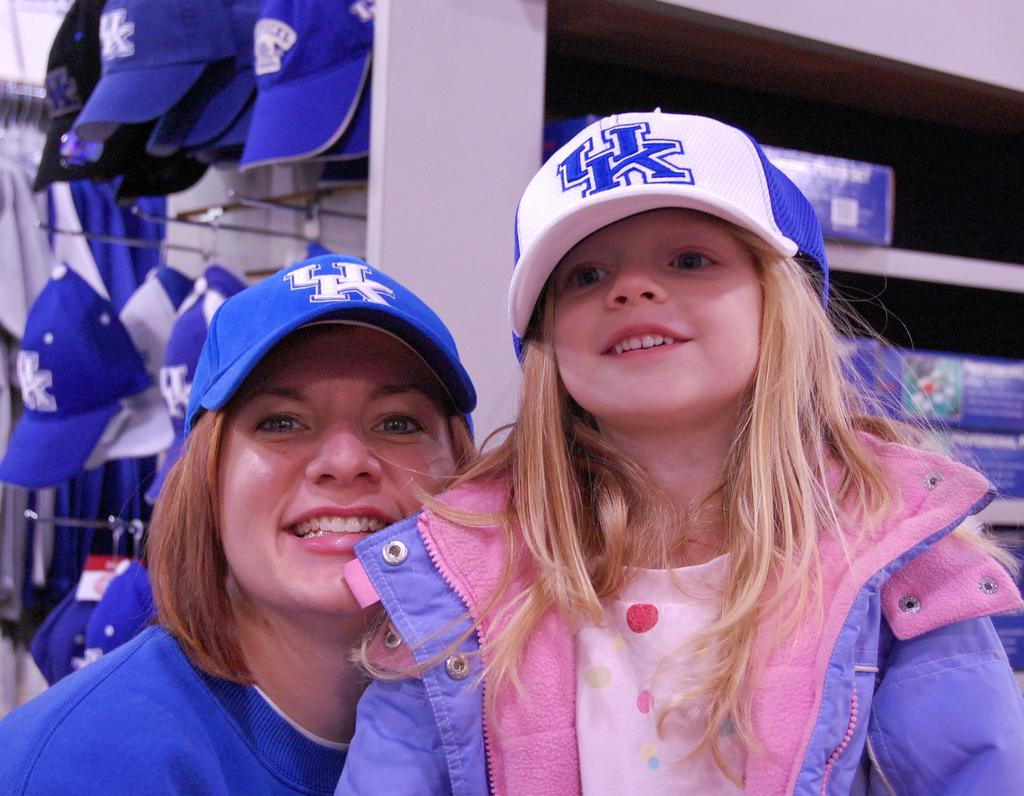Who is present in the image? There is a woman and a girl in the image. What are the woman and the girl wearing on their heads? Both the woman and the girl are wearing caps on their heads. What can be seen in the background of the image? There are caps on a stand and boxes on shelves in the background of the image. What type of sail can be seen in the image? There is no sail present in the image. Is there a stage visible in the image? There is no stage present in the image. 